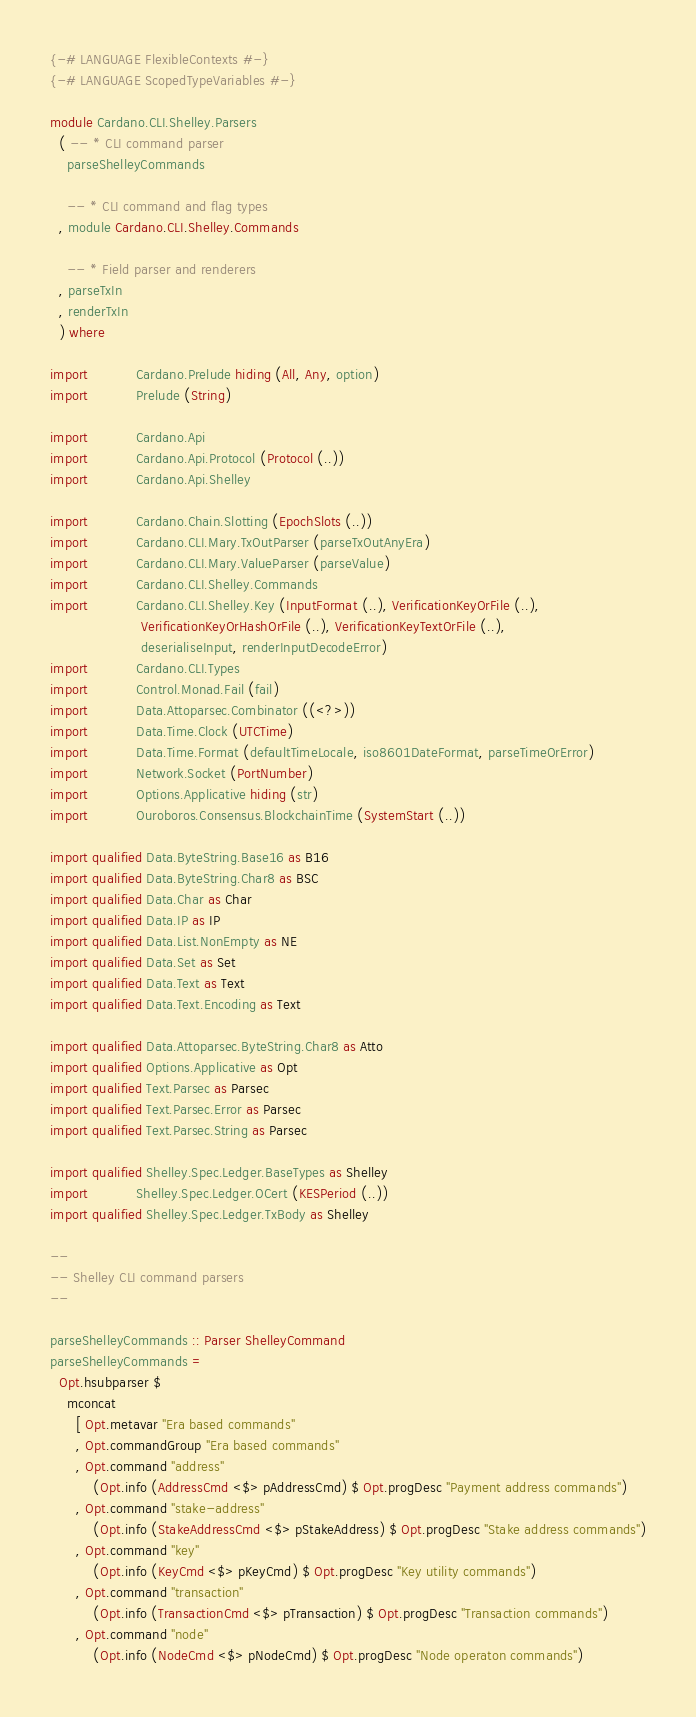<code> <loc_0><loc_0><loc_500><loc_500><_Haskell_>{-# LANGUAGE FlexibleContexts #-}
{-# LANGUAGE ScopedTypeVariables #-}

module Cardano.CLI.Shelley.Parsers
  ( -- * CLI command parser
    parseShelleyCommands

    -- * CLI command and flag types
  , module Cardano.CLI.Shelley.Commands

    -- * Field parser and renderers
  , parseTxIn
  , renderTxIn
  ) where

import           Cardano.Prelude hiding (All, Any, option)
import           Prelude (String)

import           Cardano.Api
import           Cardano.Api.Protocol (Protocol (..))
import           Cardano.Api.Shelley

import           Cardano.Chain.Slotting (EpochSlots (..))
import           Cardano.CLI.Mary.TxOutParser (parseTxOutAnyEra)
import           Cardano.CLI.Mary.ValueParser (parseValue)
import           Cardano.CLI.Shelley.Commands
import           Cardano.CLI.Shelley.Key (InputFormat (..), VerificationKeyOrFile (..),
                     VerificationKeyOrHashOrFile (..), VerificationKeyTextOrFile (..),
                     deserialiseInput, renderInputDecodeError)
import           Cardano.CLI.Types
import           Control.Monad.Fail (fail)
import           Data.Attoparsec.Combinator ((<?>))
import           Data.Time.Clock (UTCTime)
import           Data.Time.Format (defaultTimeLocale, iso8601DateFormat, parseTimeOrError)
import           Network.Socket (PortNumber)
import           Options.Applicative hiding (str)
import           Ouroboros.Consensus.BlockchainTime (SystemStart (..))

import qualified Data.ByteString.Base16 as B16
import qualified Data.ByteString.Char8 as BSC
import qualified Data.Char as Char
import qualified Data.IP as IP
import qualified Data.List.NonEmpty as NE
import qualified Data.Set as Set
import qualified Data.Text as Text
import qualified Data.Text.Encoding as Text

import qualified Data.Attoparsec.ByteString.Char8 as Atto
import qualified Options.Applicative as Opt
import qualified Text.Parsec as Parsec
import qualified Text.Parsec.Error as Parsec
import qualified Text.Parsec.String as Parsec

import qualified Shelley.Spec.Ledger.BaseTypes as Shelley
import           Shelley.Spec.Ledger.OCert (KESPeriod (..))
import qualified Shelley.Spec.Ledger.TxBody as Shelley

--
-- Shelley CLI command parsers
--

parseShelleyCommands :: Parser ShelleyCommand
parseShelleyCommands =
  Opt.hsubparser $
    mconcat
      [ Opt.metavar "Era based commands"
      , Opt.commandGroup "Era based commands"
      , Opt.command "address"
          (Opt.info (AddressCmd <$> pAddressCmd) $ Opt.progDesc "Payment address commands")
      , Opt.command "stake-address"
          (Opt.info (StakeAddressCmd <$> pStakeAddress) $ Opt.progDesc "Stake address commands")
      , Opt.command "key"
          (Opt.info (KeyCmd <$> pKeyCmd) $ Opt.progDesc "Key utility commands")
      , Opt.command "transaction"
          (Opt.info (TransactionCmd <$> pTransaction) $ Opt.progDesc "Transaction commands")
      , Opt.command "node"
          (Opt.info (NodeCmd <$> pNodeCmd) $ Opt.progDesc "Node operaton commands")</code> 